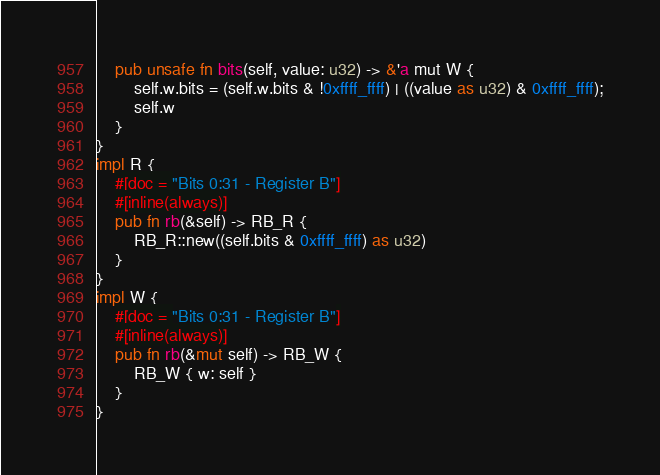<code> <loc_0><loc_0><loc_500><loc_500><_Rust_>    pub unsafe fn bits(self, value: u32) -> &'a mut W {
        self.w.bits = (self.w.bits & !0xffff_ffff) | ((value as u32) & 0xffff_ffff);
        self.w
    }
}
impl R {
    #[doc = "Bits 0:31 - Register B"]
    #[inline(always)]
    pub fn rb(&self) -> RB_R {
        RB_R::new((self.bits & 0xffff_ffff) as u32)
    }
}
impl W {
    #[doc = "Bits 0:31 - Register B"]
    #[inline(always)]
    pub fn rb(&mut self) -> RB_W {
        RB_W { w: self }
    }
}
</code> 